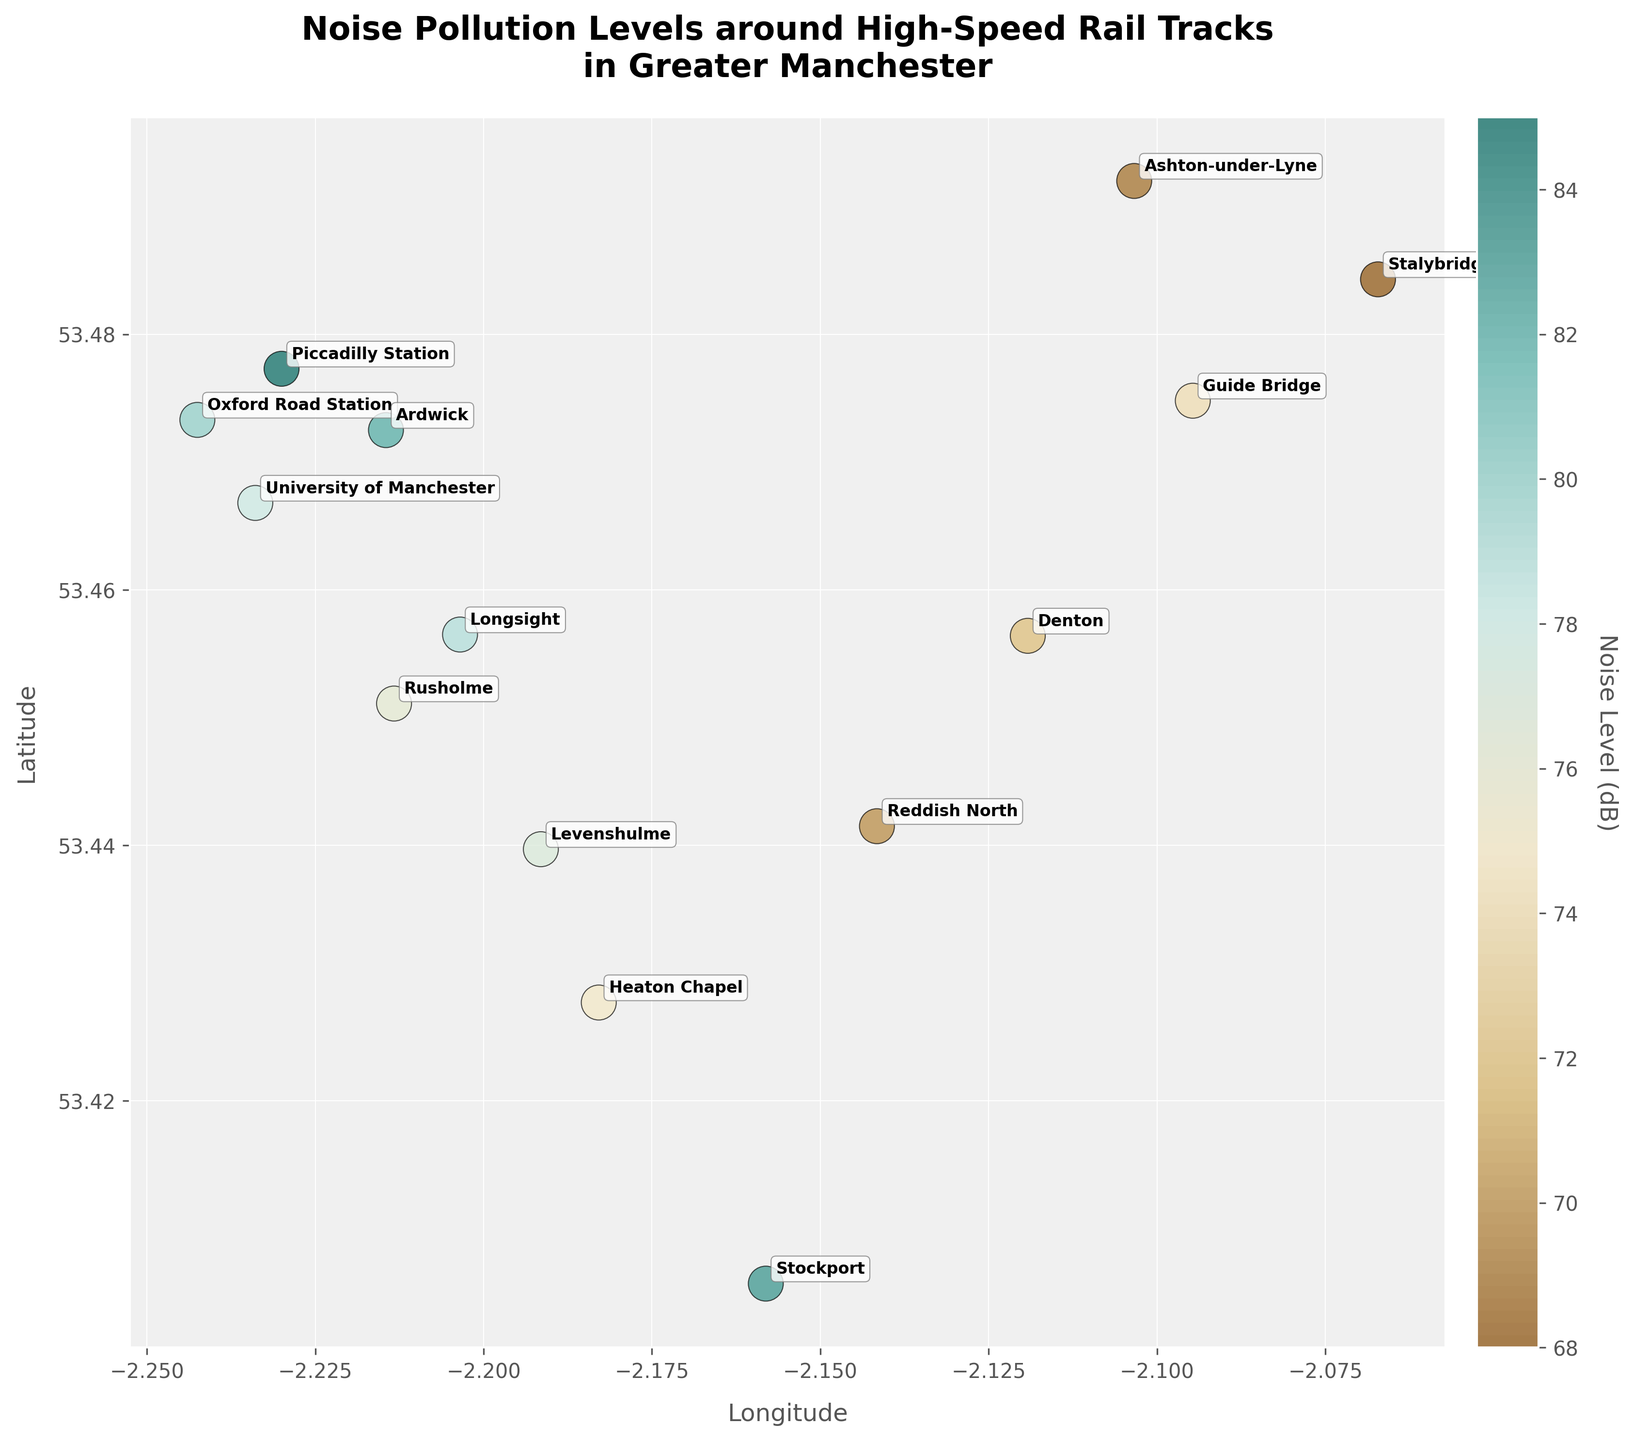What's the title of the figure? The title is typically located at the top of the figure and is often in a larger font size to make it stand out. In this case, the title is directly readable from the plot.
Answer: Noise Pollution Levels around High-Speed Rail Tracks in Greater Manchester What does the color represent in the figure? The color in the scatter plot represents the noise level in decibels (dB). This is indicated by the colorbar, which maps the colors to specific noise levels.
Answer: Noise Level (dB) How many locations have noise levels above 80 dB? By looking at the color and the data points, we can identify the locations with noise levels annotation above 80 dB. These are Piccadilly Station, Ardwick, and Stockport.
Answer: 3 What station has the highest noise level? The point with the darkest color and highest dB reading represents the highest noise level. The annotation shows the name of this location.
Answer: Piccadilly Station Which location has the lowest noise level? The color of the point with the lowest decibel (dB) value on the color bar indicates the lowest noise level. The label and color bar suggest that Stalybridge has the lowest noise level.
Answer: Stalybridge Compare the noise levels at Piccadilly Station and Stockport. Which is higher? Piccadilly Station and Stockport both have high noise levels, but we need to examine the exact dB values. Piccadilly Station has 85 dB and Stockport has 83 dB.
Answer: Piccadilly Station What is the average noise level of the locations mapped in the figure? To find the average, sum all the noise levels (sum=1108) and divide by the number of locations (14). The formula is average noise level = sum / number of locations.
Answer: 79.14 dB Which location is quieter: Reddish North or Denton? Comparing the noise levels, Reddish North has 70 dB and Denton has 72 dB. The location with the lower value is Reddish North.
Answer: Reddish North What is the noise level range in the figure? The range is determined by subtracting the lowest noise level (Stalybridge: 68 dB) from the highest noise level (Piccadilly Station: 85 dB).
Answer: 17 dB 